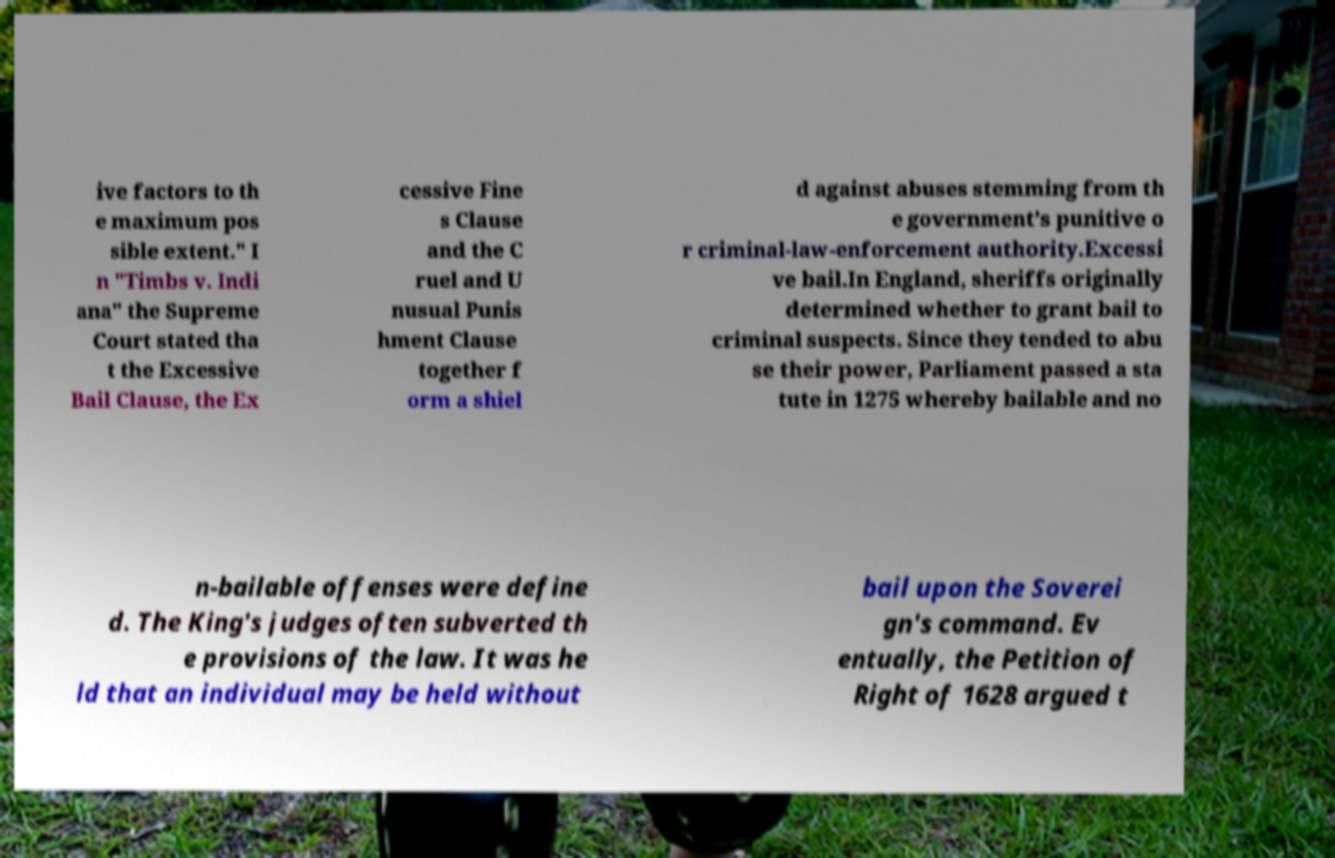Please read and relay the text visible in this image. What does it say? ive factors to th e maximum pos sible extent." I n "Timbs v. Indi ana" the Supreme Court stated tha t the Excessive Bail Clause, the Ex cessive Fine s Clause and the C ruel and U nusual Punis hment Clause together f orm a shiel d against abuses stemming from th e government’s punitive o r criminal-law-enforcement authority.Excessi ve bail.In England, sheriffs originally determined whether to grant bail to criminal suspects. Since they tended to abu se their power, Parliament passed a sta tute in 1275 whereby bailable and no n-bailable offenses were define d. The King's judges often subverted th e provisions of the law. It was he ld that an individual may be held without bail upon the Soverei gn's command. Ev entually, the Petition of Right of 1628 argued t 